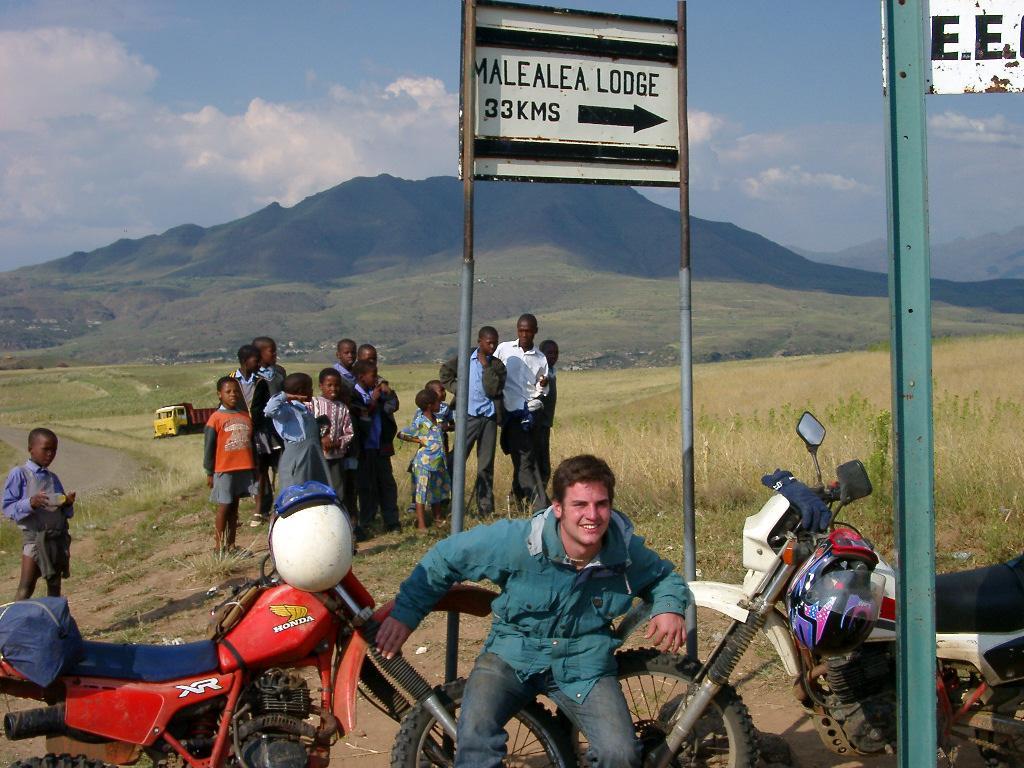Describe this image in one or two sentences. In this image there is a man sitting on the tyres. There are two motorbikes on either side of him. Behind him there is a directional board. On the right side there is an iron pole. In the background there are few kids standing on the ground. In the background there are hills. At the top there is sky. On the left side there is a lorry on the road. 